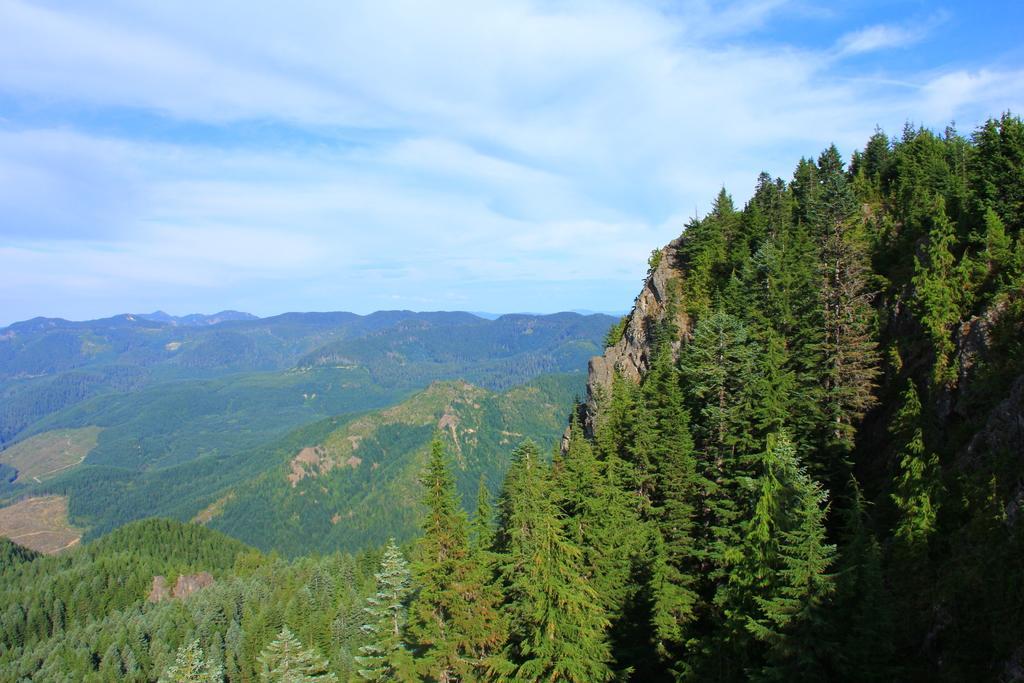In one or two sentences, can you explain what this image depicts? In this image it looks like it is a scenery in which we can see that there are so many hills. On the hills there are trees. At the top there is sky with the clouds. 